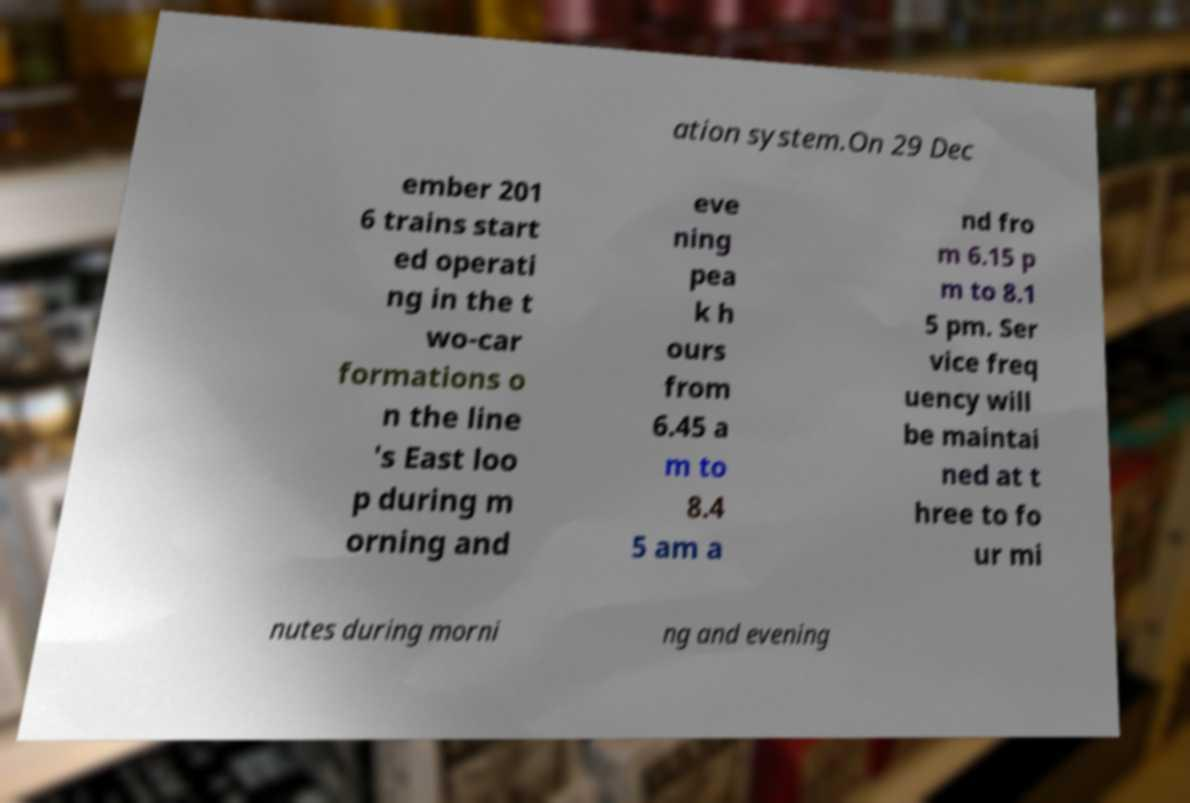Can you accurately transcribe the text from the provided image for me? ation system.On 29 Dec ember 201 6 trains start ed operati ng in the t wo-car formations o n the line 's East loo p during m orning and eve ning pea k h ours from 6.45 a m to 8.4 5 am a nd fro m 6.15 p m to 8.1 5 pm. Ser vice freq uency will be maintai ned at t hree to fo ur mi nutes during morni ng and evening 